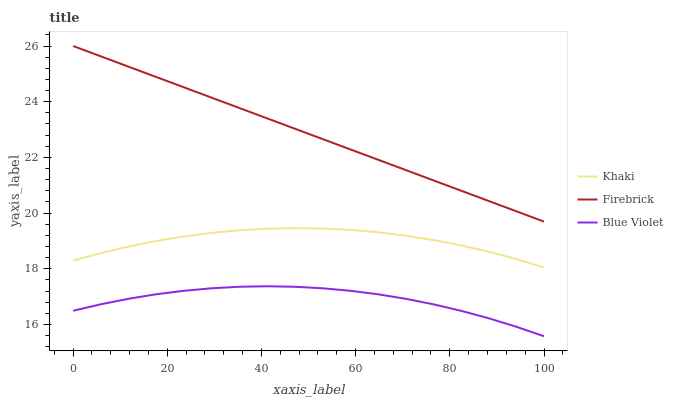Does Blue Violet have the minimum area under the curve?
Answer yes or no. Yes. Does Firebrick have the maximum area under the curve?
Answer yes or no. Yes. Does Khaki have the minimum area under the curve?
Answer yes or no. No. Does Khaki have the maximum area under the curve?
Answer yes or no. No. Is Firebrick the smoothest?
Answer yes or no. Yes. Is Blue Violet the roughest?
Answer yes or no. Yes. Is Khaki the smoothest?
Answer yes or no. No. Is Khaki the roughest?
Answer yes or no. No. Does Blue Violet have the lowest value?
Answer yes or no. Yes. Does Khaki have the lowest value?
Answer yes or no. No. Does Firebrick have the highest value?
Answer yes or no. Yes. Does Khaki have the highest value?
Answer yes or no. No. Is Blue Violet less than Firebrick?
Answer yes or no. Yes. Is Khaki greater than Blue Violet?
Answer yes or no. Yes. Does Blue Violet intersect Firebrick?
Answer yes or no. No. 